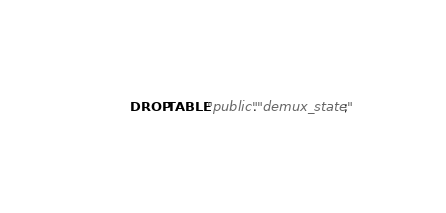<code> <loc_0><loc_0><loc_500><loc_500><_SQL_>DROP TABLE "public"."demux_state";
</code> 